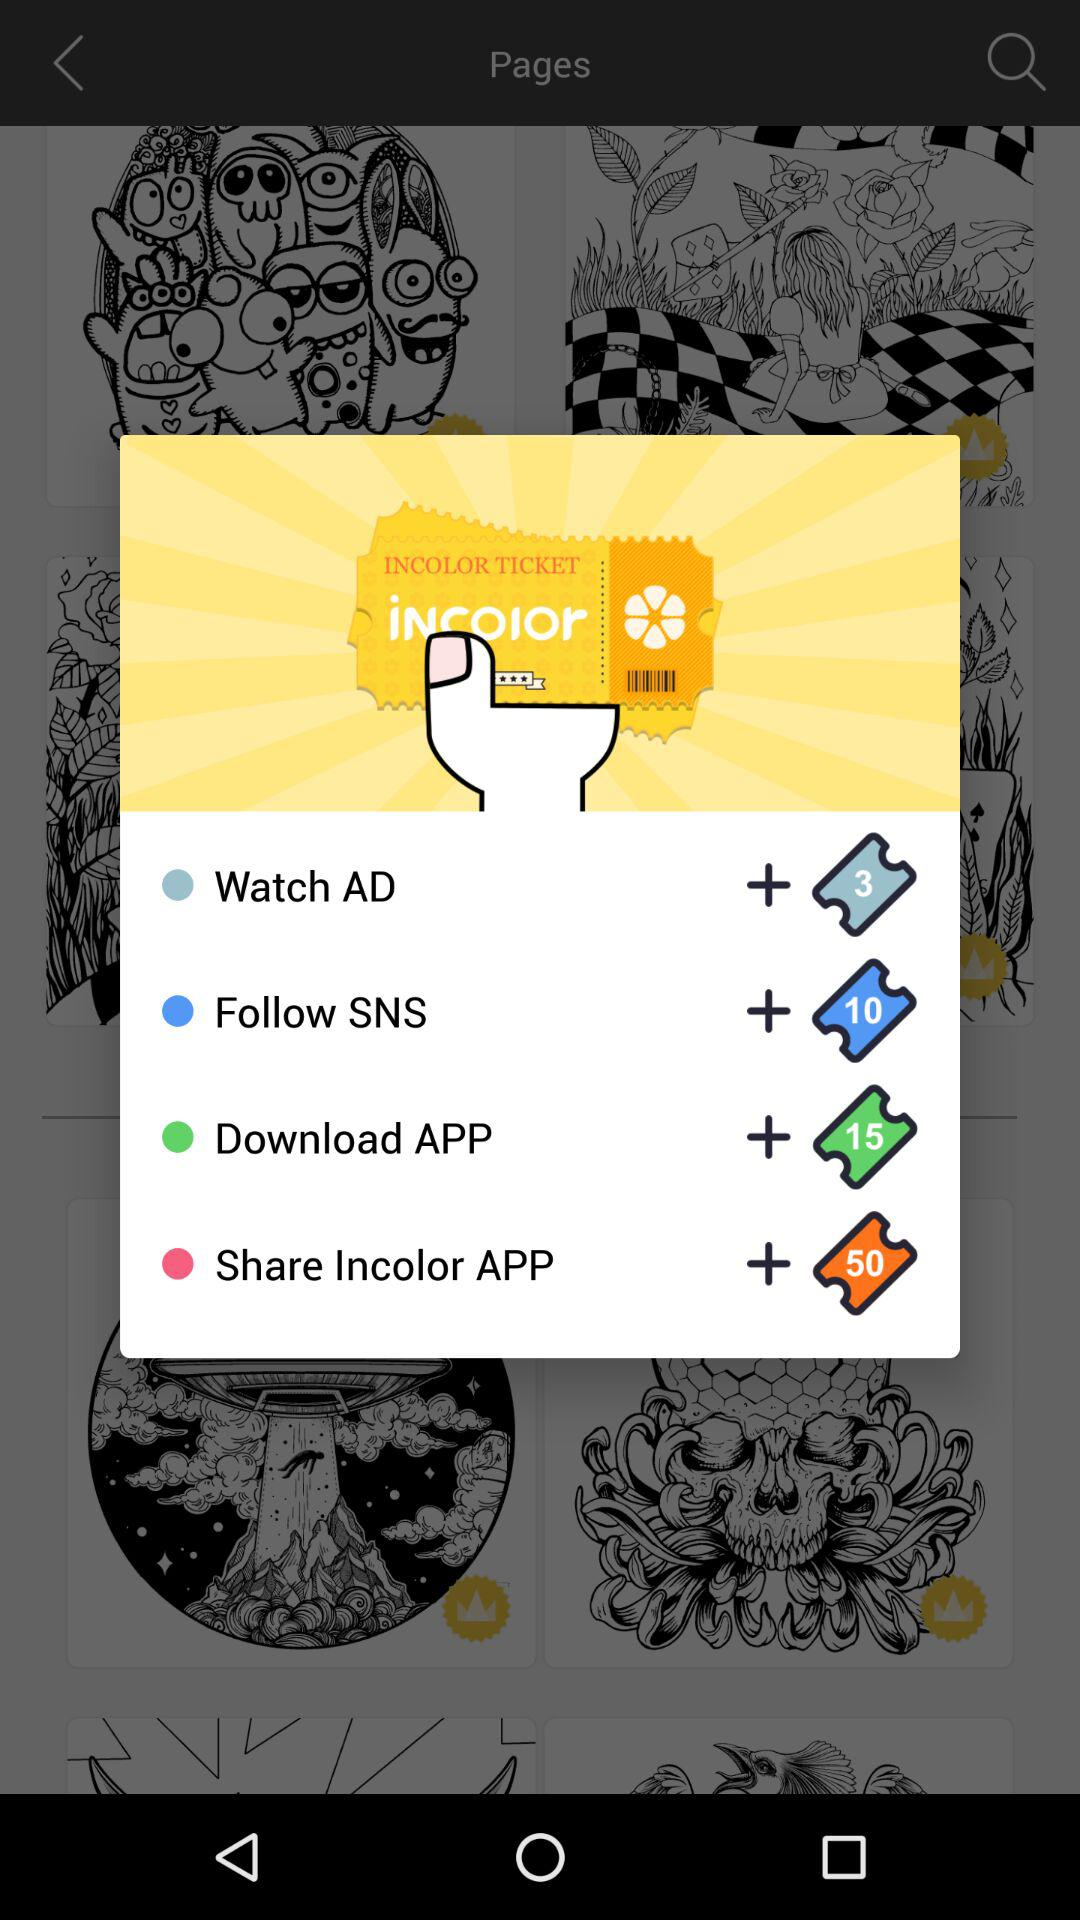What is the name of the application? The application name is "Incolor". 